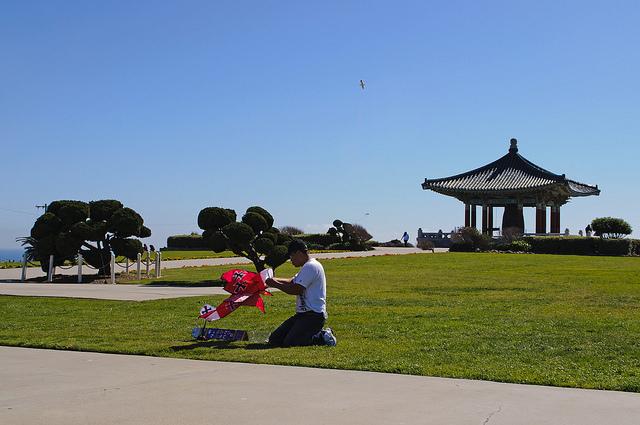What country's WWI plane is the model made to resemble?
Answer briefly. Japan. Is it sunny?
Give a very brief answer. Yes. What is the person sitting on?
Write a very short answer. Grass. Is it raining?
Keep it brief. No. How many women in the photo?
Give a very brief answer. 0. 